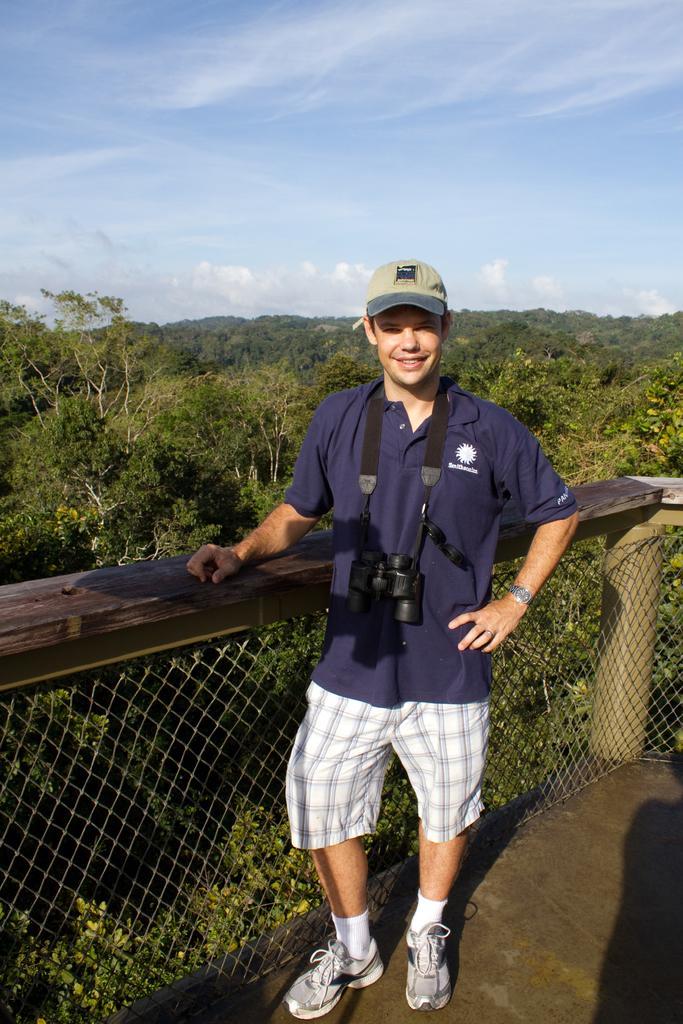Please provide a concise description of this image. In this image there is a person standing on the floor which is having fence. He is having a camera. He is wearing cap, shoes. Behind the fence there are few trees on the land. Top of the image there is sky with some clouds. 